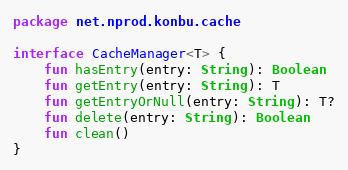Convert code to text. <code><loc_0><loc_0><loc_500><loc_500><_Kotlin_>package net.nprod.konbu.cache

interface CacheManager<T> {
    fun hasEntry(entry: String): Boolean
    fun getEntry(entry: String): T
    fun getEntryOrNull(entry: String): T?
    fun delete(entry: String): Boolean
    fun clean()
}</code> 